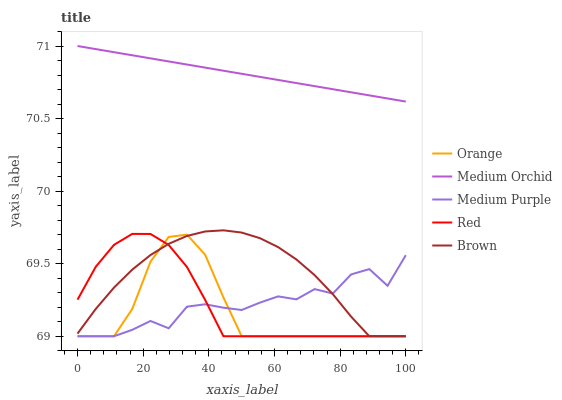Does Orange have the minimum area under the curve?
Answer yes or no. Yes. Does Medium Orchid have the maximum area under the curve?
Answer yes or no. Yes. Does Medium Purple have the minimum area under the curve?
Answer yes or no. No. Does Medium Purple have the maximum area under the curve?
Answer yes or no. No. Is Medium Orchid the smoothest?
Answer yes or no. Yes. Is Medium Purple the roughest?
Answer yes or no. Yes. Is Medium Purple the smoothest?
Answer yes or no. No. Is Medium Orchid the roughest?
Answer yes or no. No. Does Medium Orchid have the lowest value?
Answer yes or no. No. Does Medium Orchid have the highest value?
Answer yes or no. Yes. Does Medium Purple have the highest value?
Answer yes or no. No. Is Red less than Medium Orchid?
Answer yes or no. Yes. Is Medium Orchid greater than Brown?
Answer yes or no. Yes. Does Red intersect Medium Purple?
Answer yes or no. Yes. Is Red less than Medium Purple?
Answer yes or no. No. Is Red greater than Medium Purple?
Answer yes or no. No. Does Red intersect Medium Orchid?
Answer yes or no. No. 